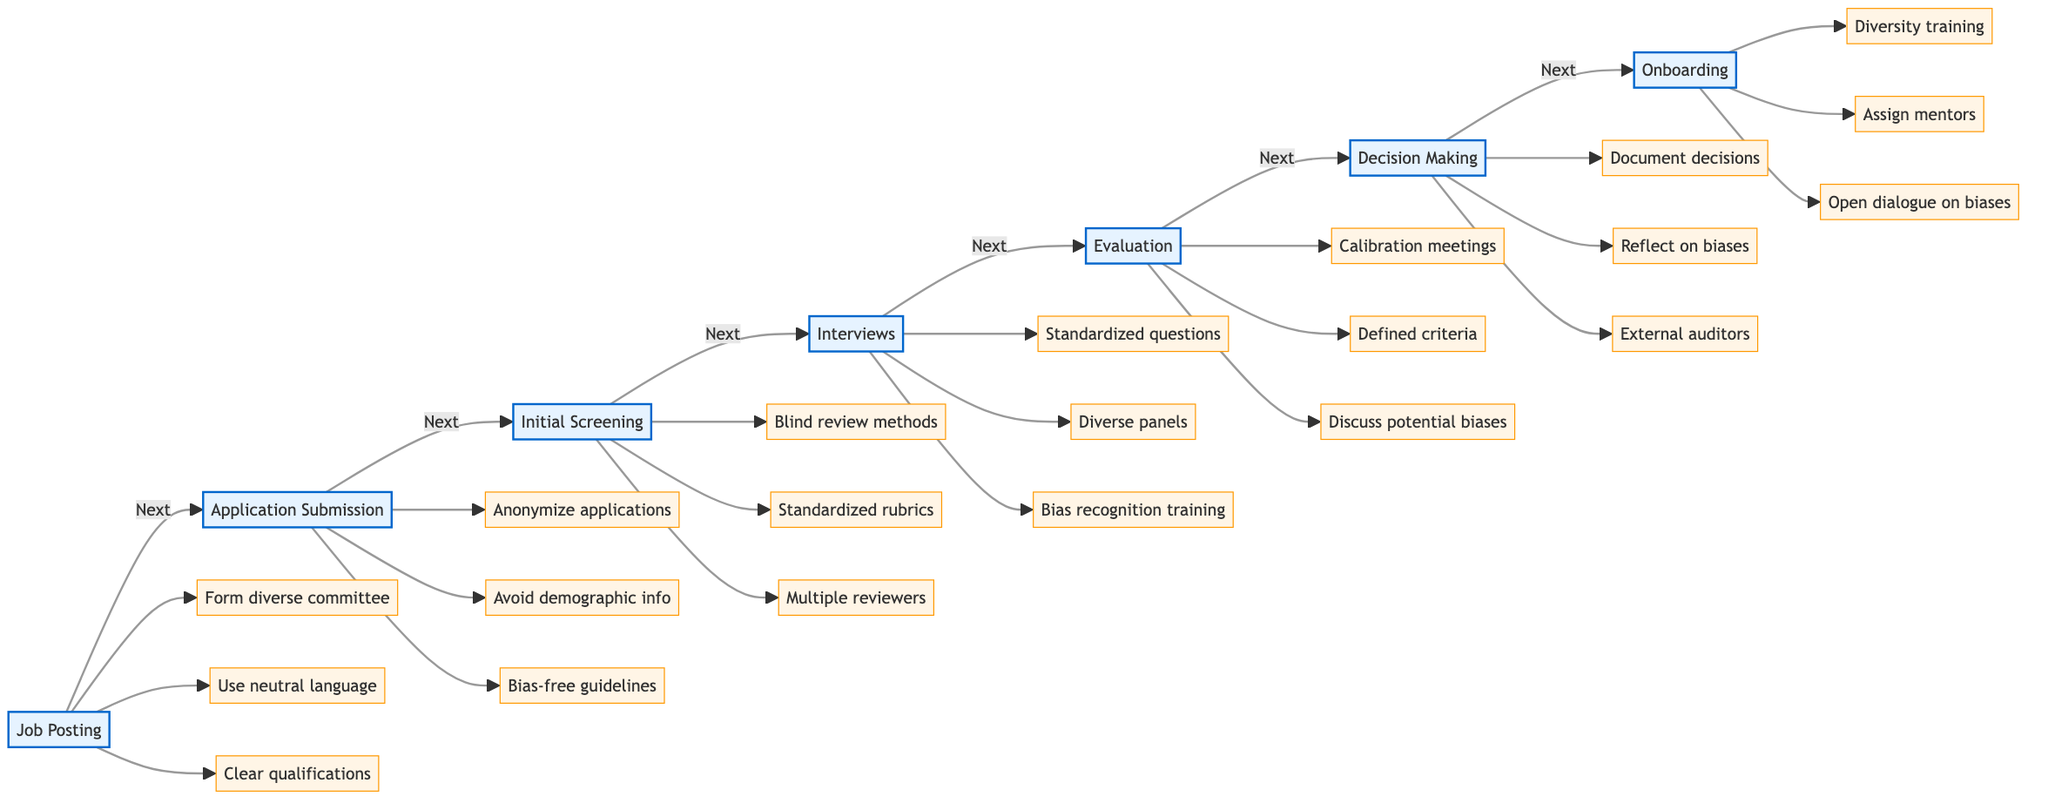What is the first step in the academic job application process? The first step in the diagram is "Job Posting," which is the initial stage that sets the foundation for the hiring process.
Answer: Job Posting How many actions are listed under the "Application Submission" step? In the "Application Submission" step, there are three actions listed: anonymize applications, avoid demographic info, and provide bias-free guidelines.
Answer: 3 What is the action related to blind review methods? The action related to blind review methods is found in the "Initial Screening" step where it states to employ blind review methods to minimize implicit bias.
Answer: Employ blind review methods What type of panels should conduct interviews according to the diagram? The diagram specifies that interviews should have "diverse interview panels," highlighting the importance of representation during the interview process.
Answer: Diverse panels Which step involves documentation of hiring decisions? The documentation of hiring decisions occurs in the "Decision Making" step, as indicated. This emphasizes the need for transparency in the hiring process.
Answer: Decision Making What do calibration meetings aim to address in the evaluation step? Calibration meetings in the "Evaluation" step aim to compare assessments among committee members to enhance consensus and reduce personal biases.
Answer: Compare assessments What is a key action to take during onboarding? A key action during "Onboarding" is to provide training on workplace diversity and inclusion, which is essential for fostering an inclusive environment for new hires.
Answer: Diversity training How does the diagram suggest reducing ambiguity in job qualifications? The diagram suggests reducing ambiguity by listing qualifications clearly in the "Job Posting" step, helping ensure that all candidates understand the requirements.
Answer: Clear qualifications What should interviewers receive training on? According to the diagram, interviewers should receive training on recognizing and countering bias to improve fairness in the evaluation process.
Answer: Recognizing and countering bias 